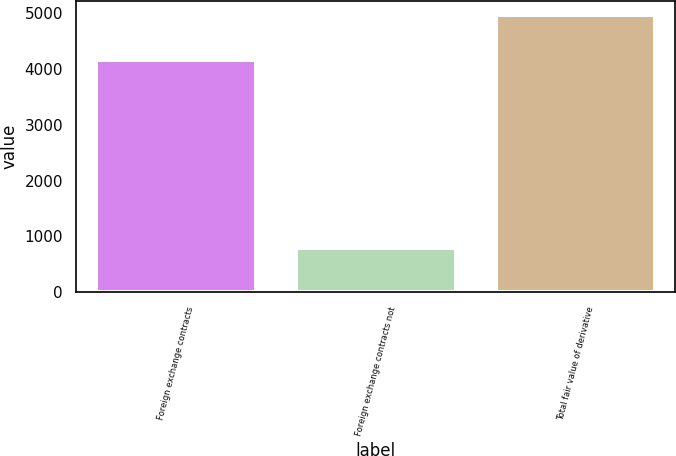<chart> <loc_0><loc_0><loc_500><loc_500><bar_chart><fcel>Foreign exchange contracts<fcel>Foreign exchange contracts not<fcel>Total fair value of derivative<nl><fcel>4162<fcel>801<fcel>4963<nl></chart> 